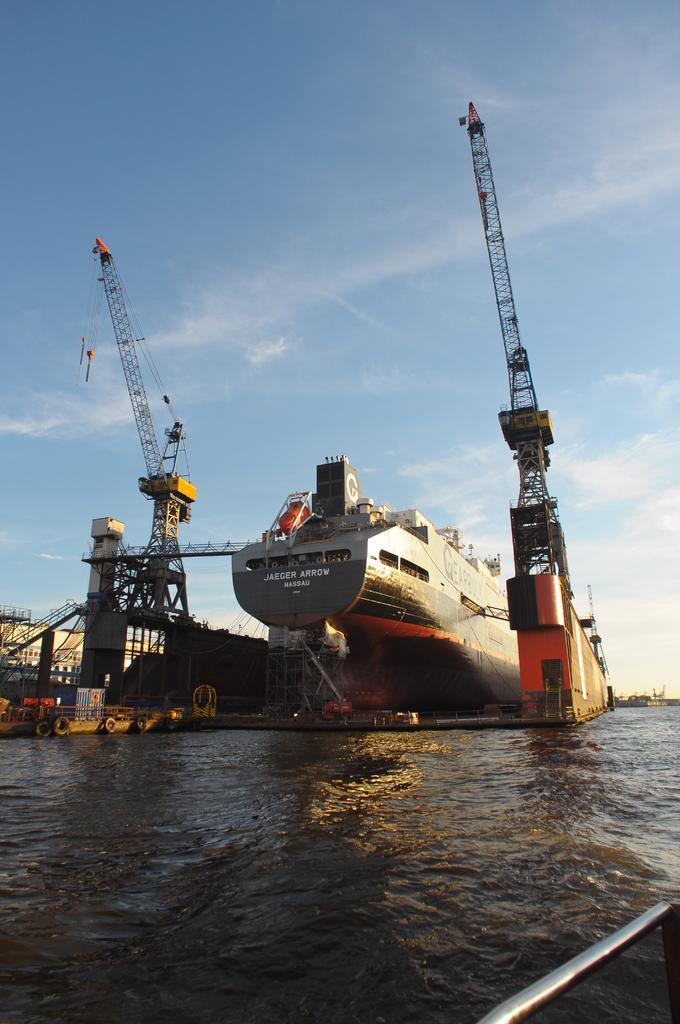Can you describe this image briefly? In this image in the center there is a ship and there are cranes. In the front there is water and the sky is cloudy. 